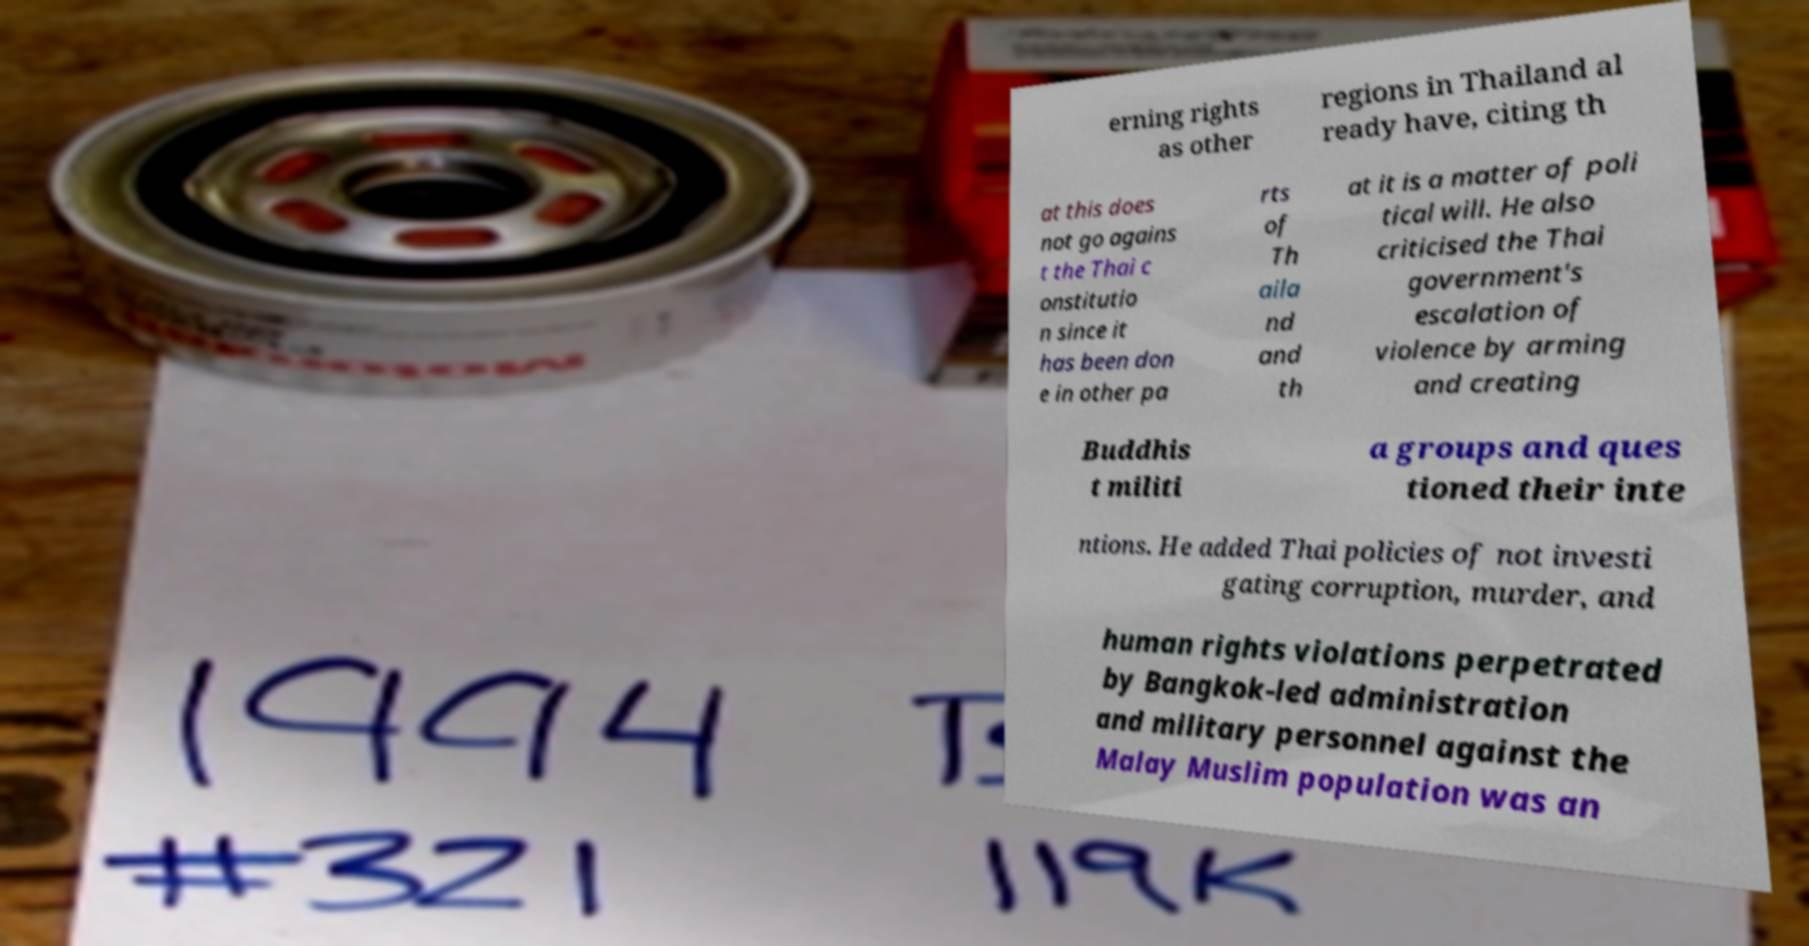Could you extract and type out the text from this image? erning rights as other regions in Thailand al ready have, citing th at this does not go agains t the Thai c onstitutio n since it has been don e in other pa rts of Th aila nd and th at it is a matter of poli tical will. He also criticised the Thai government's escalation of violence by arming and creating Buddhis t militi a groups and ques tioned their inte ntions. He added Thai policies of not investi gating corruption, murder, and human rights violations perpetrated by Bangkok-led administration and military personnel against the Malay Muslim population was an 